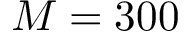Convert formula to latex. <formula><loc_0><loc_0><loc_500><loc_500>M = 3 0 0</formula> 